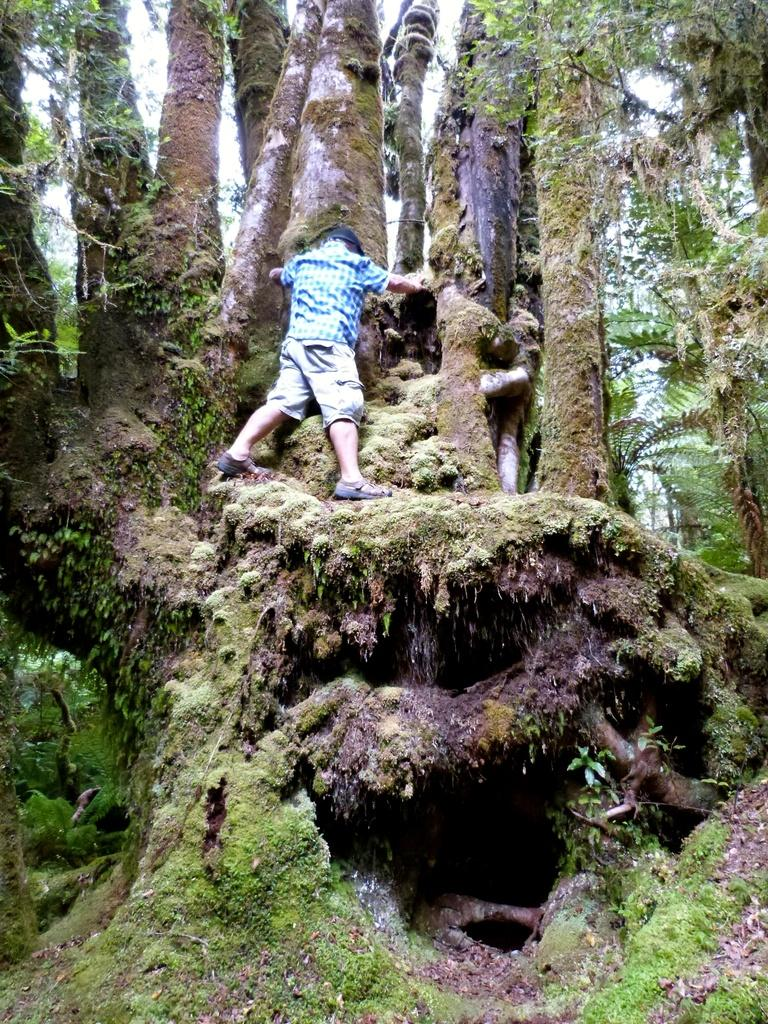Who is the main subject in the image? There is a boy in the image. What is the boy doing in the image? The boy is climbing a tree. What can be seen in the background of the image? There are trees in the background of the image. What type of terrain is visible at the bottom of the image? There is grass at the bottom of the image. What type of country music band is performing in the image? There is no country music band present in the image; it features a boy climbing a tree. How is the oil being used in the image? There is no oil present in the image. 